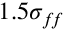Convert formula to latex. <formula><loc_0><loc_0><loc_500><loc_500>1 . 5 \sigma _ { f \, f }</formula> 